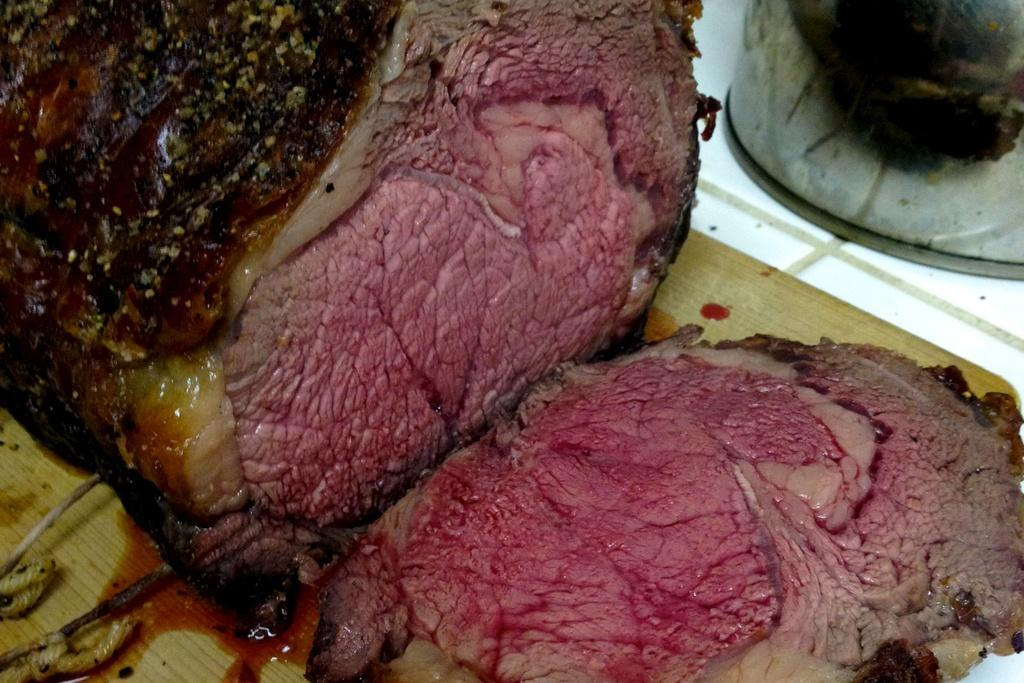What type of food is the main subject of the image? There is a roast beef in the image. What is the roast beef placed on? The roast beef is on a wooden board. What grade does the roast beef receive for its presentation in the image? There is no grading system or evaluation present in the image, so it cannot be determined how the roast beef's presentation is being judged. 